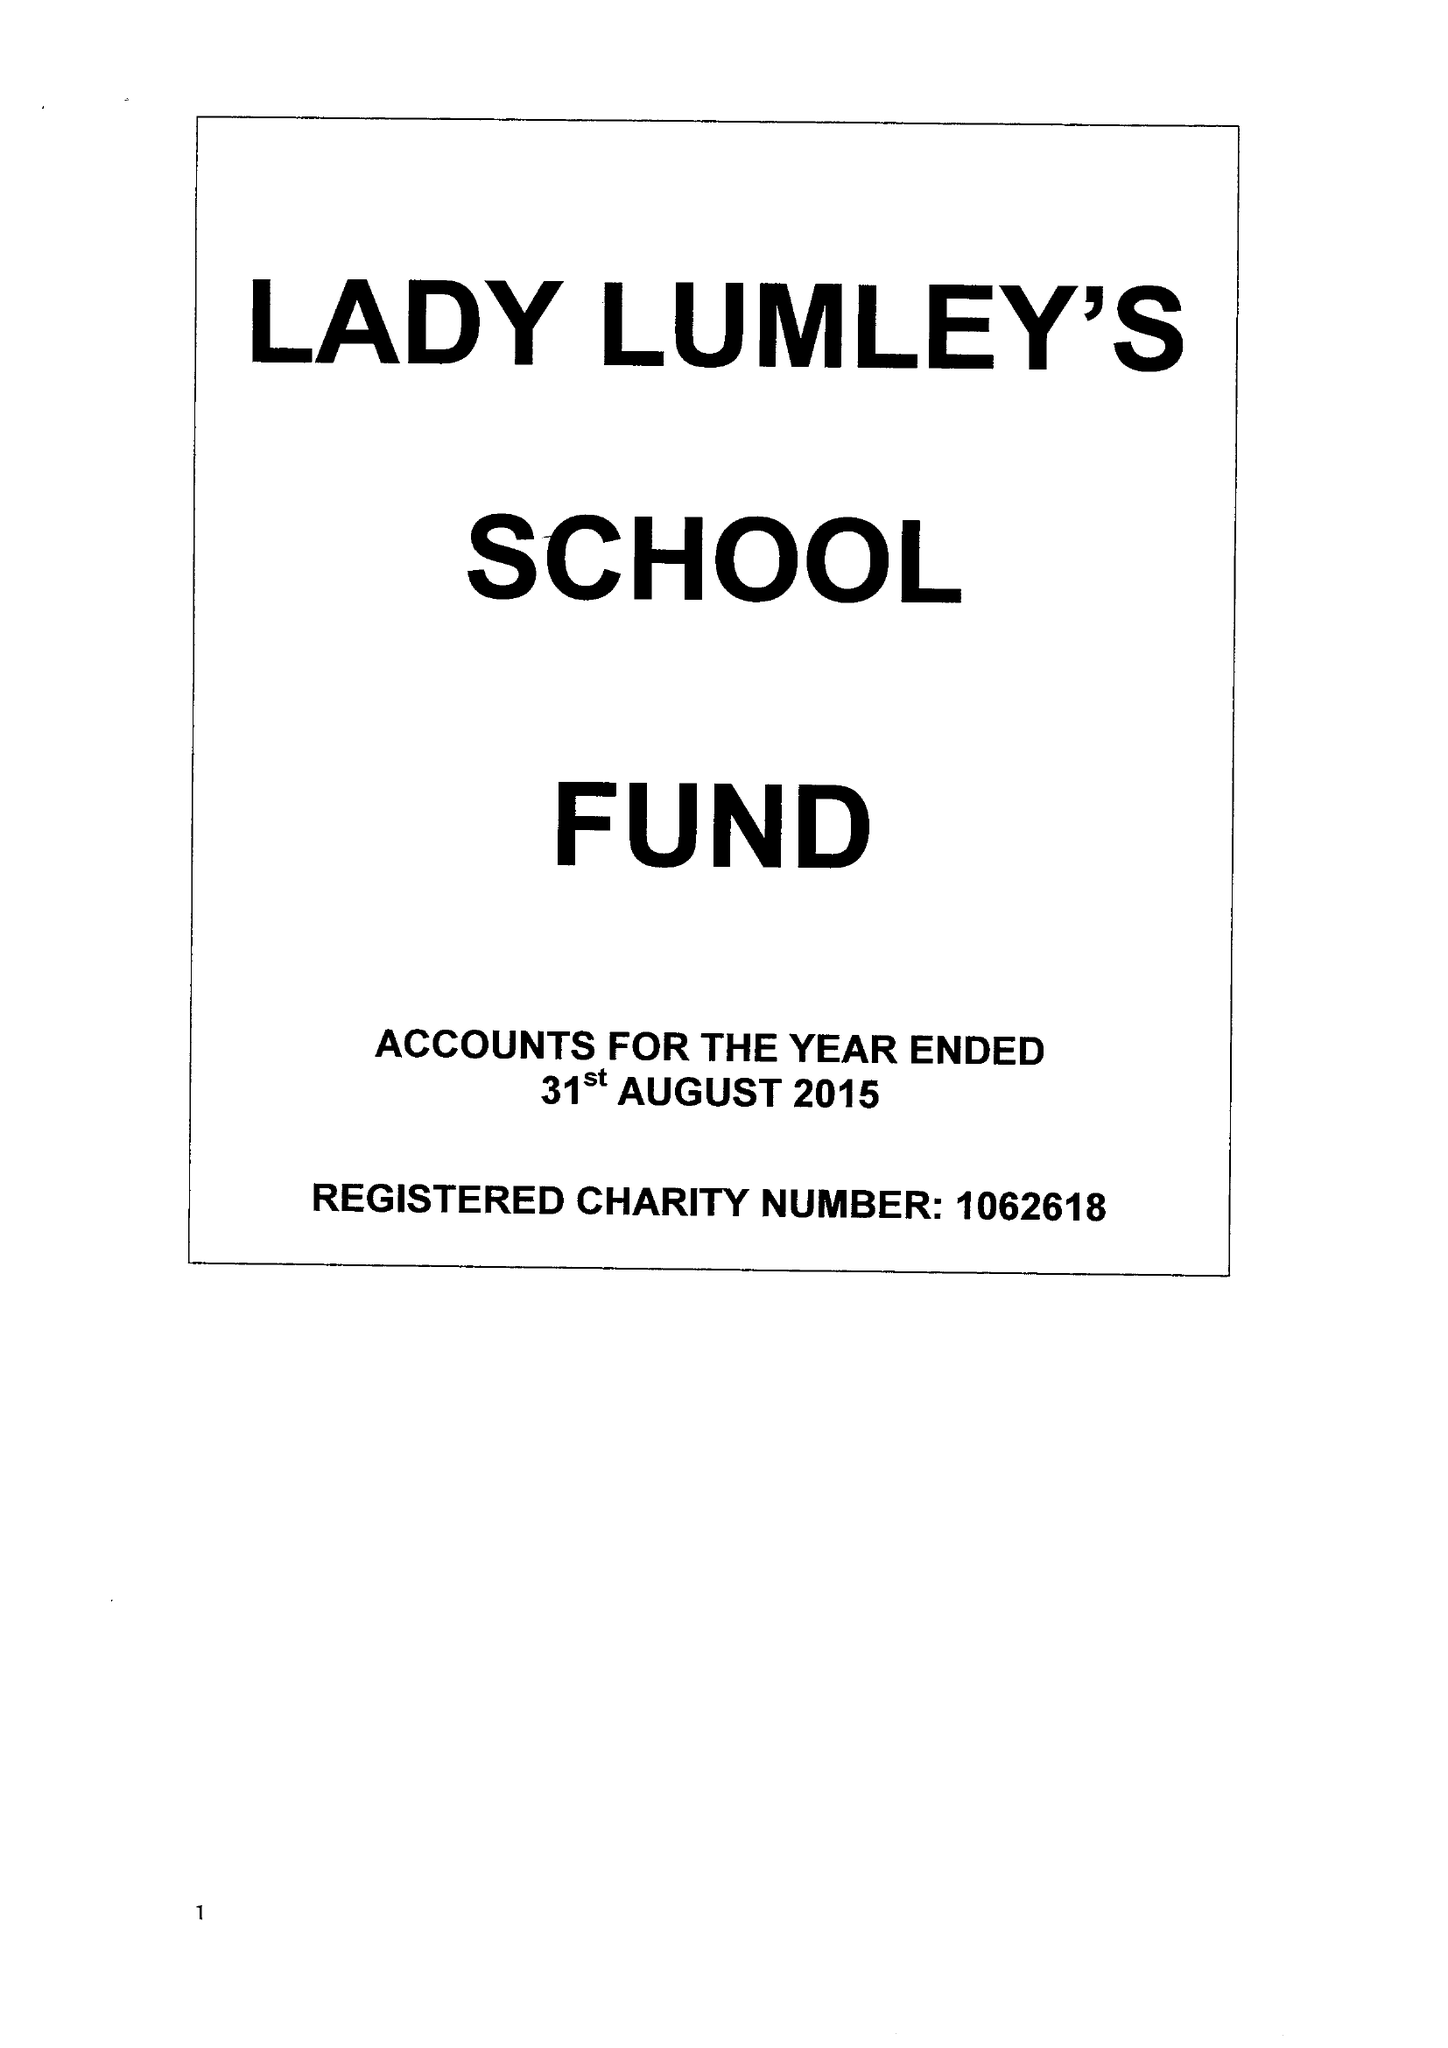What is the value for the spending_annually_in_british_pounds?
Answer the question using a single word or phrase. 154648.00 